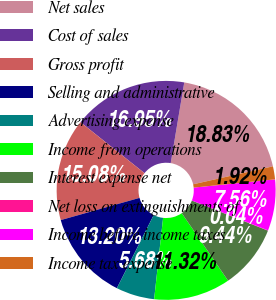<chart> <loc_0><loc_0><loc_500><loc_500><pie_chart><fcel>Net sales<fcel>Cost of sales<fcel>Gross profit<fcel>Selling and administrative<fcel>Advertising expense<fcel>Income from operations<fcel>Interest expense net<fcel>Net loss on extinguishments of<fcel>Income before income taxes<fcel>Income tax expense<nl><fcel>18.83%<fcel>16.95%<fcel>15.08%<fcel>13.2%<fcel>5.68%<fcel>11.32%<fcel>9.44%<fcel>0.04%<fcel>7.56%<fcel>1.92%<nl></chart> 